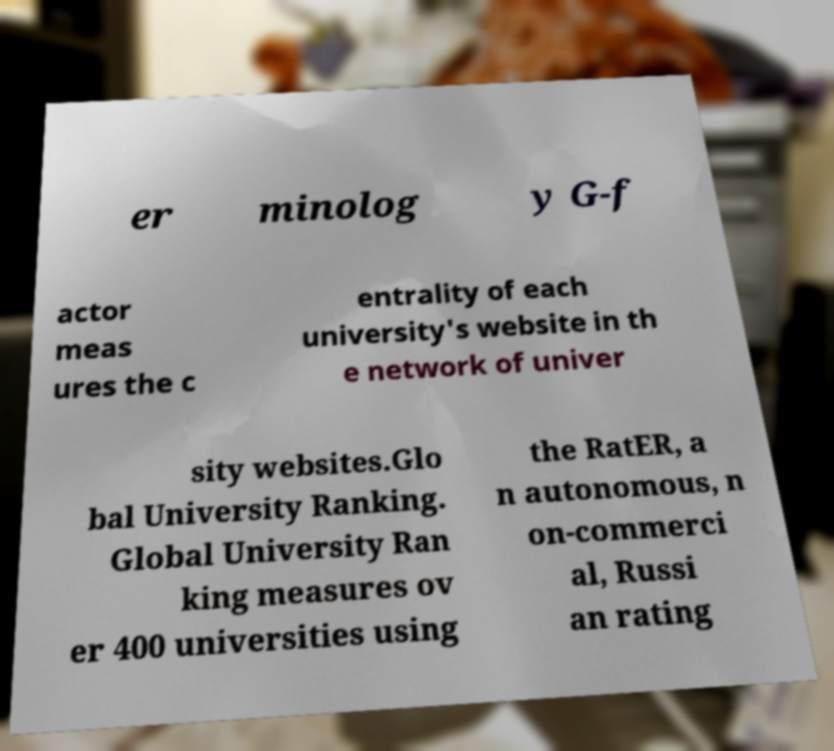Could you assist in decoding the text presented in this image and type it out clearly? er minolog y G-f actor meas ures the c entrality of each university's website in th e network of univer sity websites.Glo bal University Ranking. Global University Ran king measures ov er 400 universities using the RatER, a n autonomous, n on-commerci al, Russi an rating 